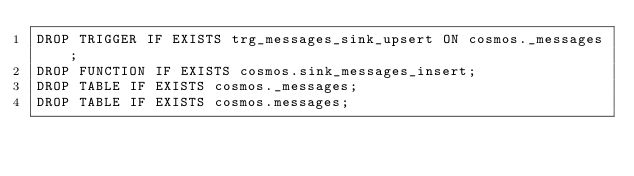Convert code to text. <code><loc_0><loc_0><loc_500><loc_500><_SQL_>DROP TRIGGER IF EXISTS trg_messages_sink_upsert ON cosmos._messages;
DROP FUNCTION IF EXISTS cosmos.sink_messages_insert;
DROP TABLE IF EXISTS cosmos._messages;
DROP TABLE IF EXISTS cosmos.messages;</code> 